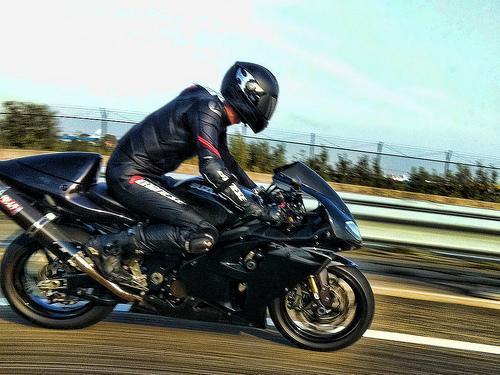How many people are shown?
Give a very brief answer. 1. How many people are wearing helmets in the image?
Give a very brief answer. 1. 